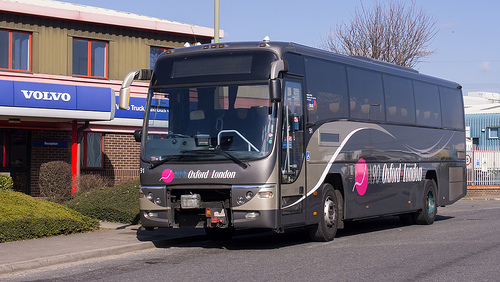Please provide a short description for this region: [0.3, 0.51, 0.49, 0.56]. This depicts the black windshield wipers of a gray bus, currently retracted and unused, standing out starkly against the light backdrop. 